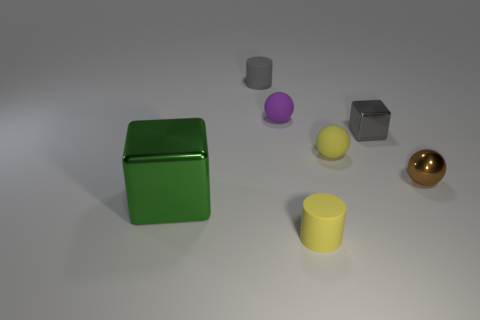Is there a tiny purple thing in front of the thing that is on the right side of the small gray thing that is to the right of the small gray matte cylinder?
Provide a succinct answer. No. What is the material of the tiny gray thing that is the same shape as the green thing?
Give a very brief answer. Metal. There is a object that is on the left side of the tiny gray cylinder; how many yellow matte things are behind it?
Offer a terse response. 1. What is the size of the metal object that is left of the yellow object that is in front of the yellow rubber object that is behind the big green metal object?
Offer a terse response. Large. There is a small cylinder behind the metallic object that is to the right of the tiny cube; what is its color?
Keep it short and to the point. Gray. What number of other objects are the same material as the small purple object?
Provide a succinct answer. 3. How many other things are the same color as the large object?
Offer a very short reply. 0. What is the material of the cube that is on the right side of the small cylinder behind the purple sphere?
Offer a very short reply. Metal. Are there any large blue shiny cylinders?
Give a very brief answer. No. What is the size of the purple object behind the matte ball that is to the right of the small purple rubber ball?
Your answer should be very brief. Small. 